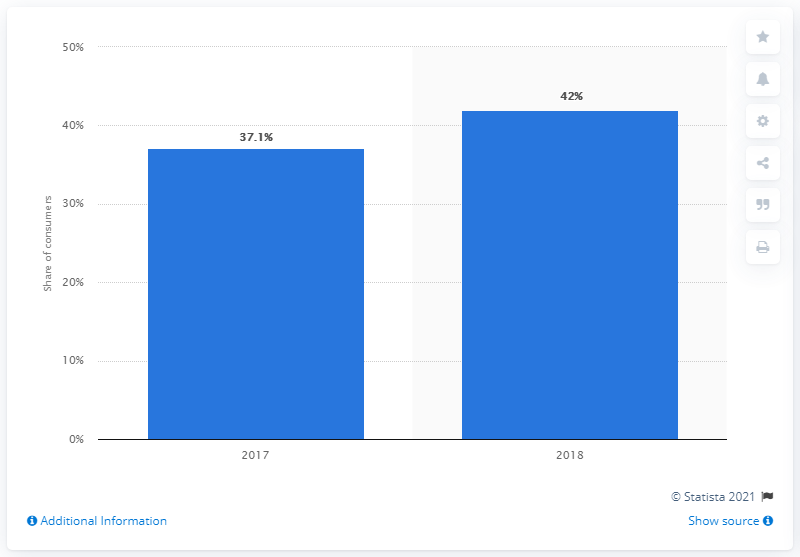Give some essential details in this illustration. In the previous year, 37.1% of online retail customers in the UK were able to track their orders. 